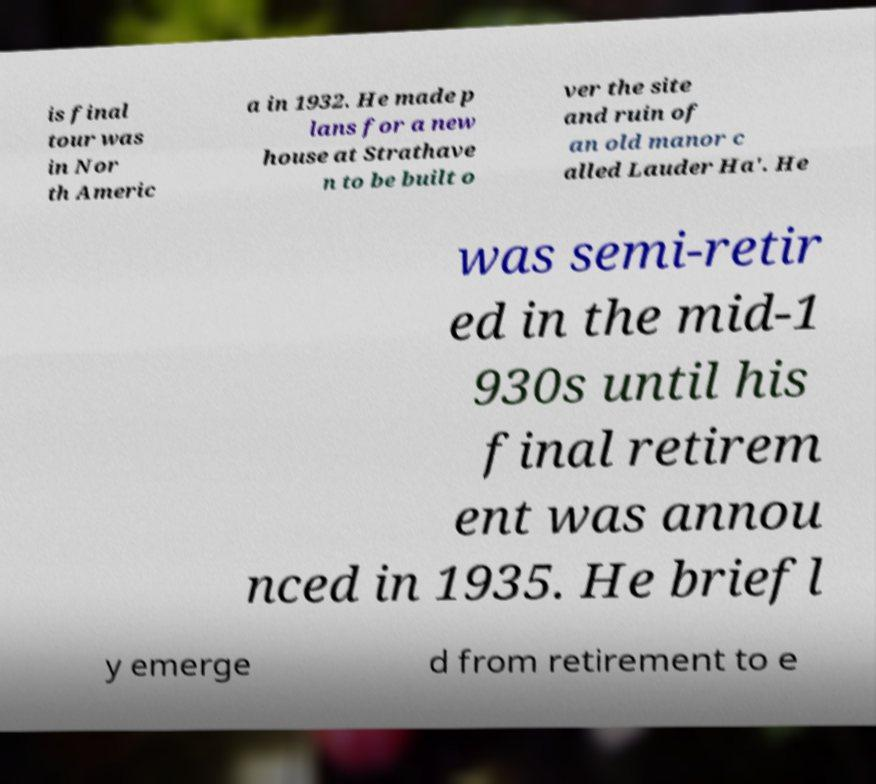For documentation purposes, I need the text within this image transcribed. Could you provide that? is final tour was in Nor th Americ a in 1932. He made p lans for a new house at Strathave n to be built o ver the site and ruin of an old manor c alled Lauder Ha'. He was semi-retir ed in the mid-1 930s until his final retirem ent was annou nced in 1935. He briefl y emerge d from retirement to e 